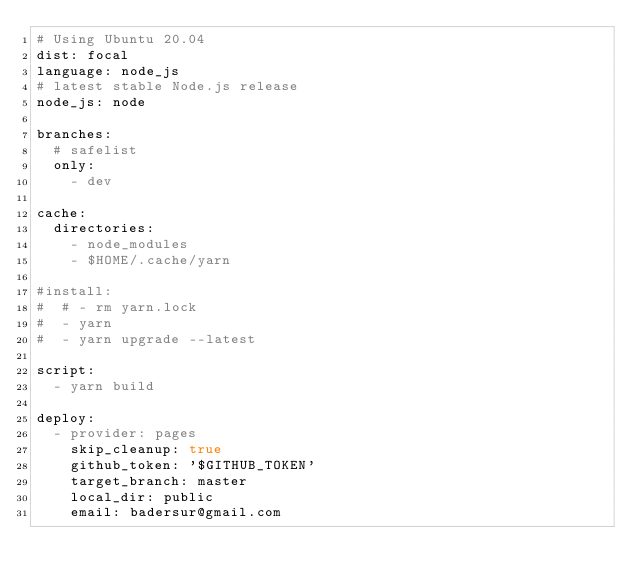Convert code to text. <code><loc_0><loc_0><loc_500><loc_500><_YAML_># Using Ubuntu 20.04
dist: focal
language: node_js
# latest stable Node.js release
node_js: node

branches:
  # safelist
  only:
    - dev

cache:
  directories:
    - node_modules
    - $HOME/.cache/yarn

#install:
#  # - rm yarn.lock
#  - yarn
#  - yarn upgrade --latest

script:
  - yarn build

deploy:
  - provider: pages
    skip_cleanup: true
    github_token: '$GITHUB_TOKEN'
    target_branch: master
    local_dir: public
    email: badersur@gmail.com</code> 